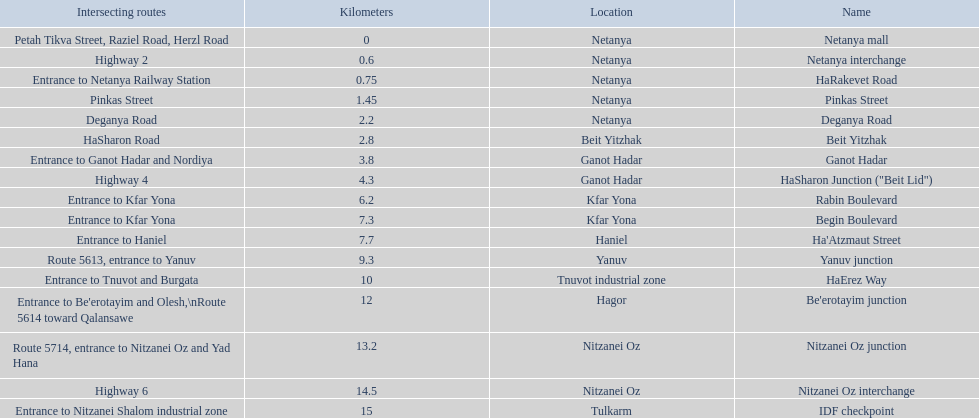What are all the names? Netanya mall, Netanya interchange, HaRakevet Road, Pinkas Street, Deganya Road, Beit Yitzhak, Ganot Hadar, HaSharon Junction ("Beit Lid"), Rabin Boulevard, Begin Boulevard, Ha'Atzmaut Street, Yanuv junction, HaErez Way, Be'erotayim junction, Nitzanei Oz junction, Nitzanei Oz interchange, IDF checkpoint. Where do they intersect? Petah Tikva Street, Raziel Road, Herzl Road, Highway 2, Entrance to Netanya Railway Station, Pinkas Street, Deganya Road, HaSharon Road, Entrance to Ganot Hadar and Nordiya, Highway 4, Entrance to Kfar Yona, Entrance to Kfar Yona, Entrance to Haniel, Route 5613, entrance to Yanuv, Entrance to Tnuvot and Burgata, Entrance to Be'erotayim and Olesh,\nRoute 5614 toward Qalansawe, Route 5714, entrance to Nitzanei Oz and Yad Hana, Highway 6, Entrance to Nitzanei Shalom industrial zone. And which shares an intersection with rabin boulevard? Begin Boulevard. Give me the full table as a dictionary. {'header': ['Intersecting routes', 'Kilometers', 'Location', 'Name'], 'rows': [['Petah Tikva Street, Raziel Road, Herzl Road', '0', 'Netanya', 'Netanya mall'], ['Highway 2', '0.6', 'Netanya', 'Netanya interchange'], ['Entrance to Netanya Railway Station', '0.75', 'Netanya', 'HaRakevet Road'], ['Pinkas Street', '1.45', 'Netanya', 'Pinkas Street'], ['Deganya Road', '2.2', 'Netanya', 'Deganya Road'], ['HaSharon Road', '2.8', 'Beit Yitzhak', 'Beit Yitzhak'], ['Entrance to Ganot Hadar and Nordiya', '3.8', 'Ganot Hadar', 'Ganot Hadar'], ['Highway 4', '4.3', 'Ganot Hadar', 'HaSharon Junction ("Beit Lid")'], ['Entrance to Kfar Yona', '6.2', 'Kfar Yona', 'Rabin Boulevard'], ['Entrance to Kfar Yona', '7.3', 'Kfar Yona', 'Begin Boulevard'], ['Entrance to Haniel', '7.7', 'Haniel', "Ha'Atzmaut Street"], ['Route 5613, entrance to Yanuv', '9.3', 'Yanuv', 'Yanuv junction'], ['Entrance to Tnuvot and Burgata', '10', 'Tnuvot industrial zone', 'HaErez Way'], ["Entrance to Be'erotayim and Olesh,\\nRoute 5614 toward Qalansawe", '12', 'Hagor', "Be'erotayim junction"], ['Route 5714, entrance to Nitzanei Oz and Yad Hana', '13.2', 'Nitzanei Oz', 'Nitzanei Oz junction'], ['Highway 6', '14.5', 'Nitzanei Oz', 'Nitzanei Oz interchange'], ['Entrance to Nitzanei Shalom industrial zone', '15', 'Tulkarm', 'IDF checkpoint']]} 